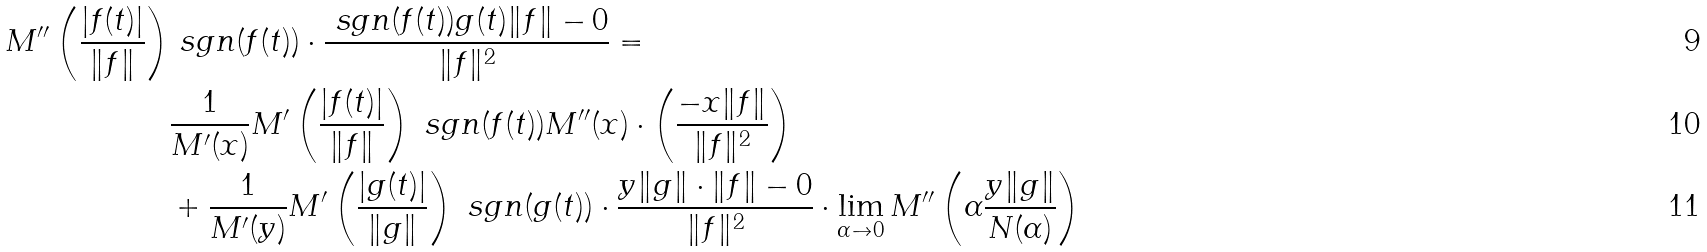<formula> <loc_0><loc_0><loc_500><loc_500>M ^ { \prime \prime } \left ( \frac { | f ( t ) | } { \| f \| } \right ) & \ s g n ( f ( t ) ) \cdot \frac { \ s g n ( f ( t ) ) g ( t ) \| f \| - 0 } { \| f \| ^ { 2 } } = \\ & \frac { 1 } { M ^ { \prime } ( x ) } M ^ { \prime } \left ( \frac { | f ( t ) | } { \| f \| } \right ) \ s g n ( f ( t ) ) M ^ { \prime \prime } ( x ) \cdot \left ( \frac { - x \| f \| } { \| f \| ^ { 2 } } \right ) \\ & + \frac { 1 } { M ^ { \prime } ( y ) } M ^ { \prime } \left ( \frac { | g ( t ) | } { \| g \| } \right ) \ s g n ( g ( t ) ) \cdot \frac { y \| g \| \cdot \| f \| - 0 } { \| f \| ^ { 2 } } \cdot \lim _ { \alpha \to 0 } M ^ { \prime \prime } \left ( \alpha \frac { y \| g \| } { N ( \alpha ) } \right )</formula> 